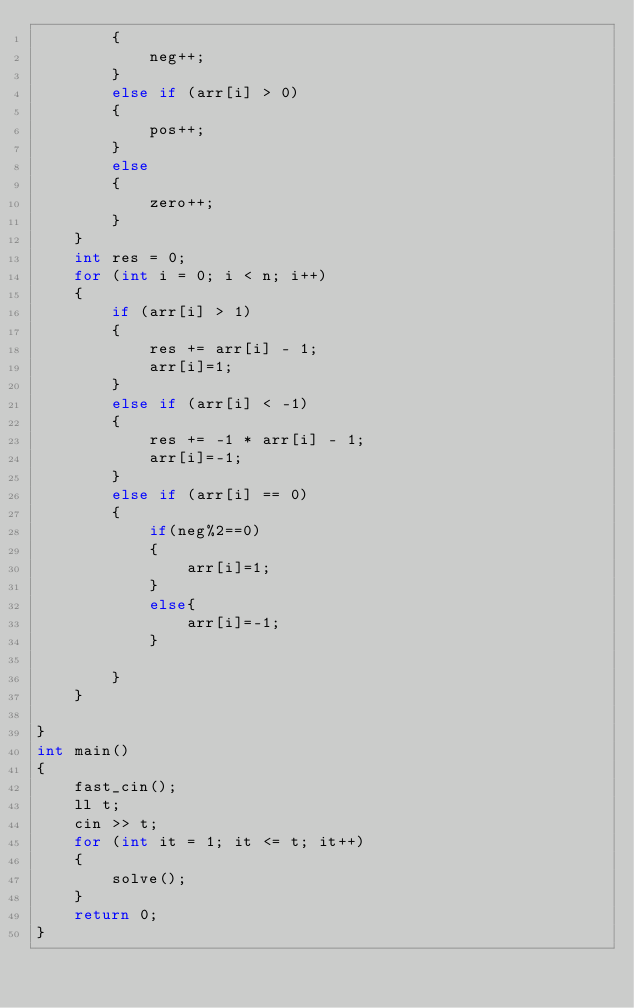Convert code to text. <code><loc_0><loc_0><loc_500><loc_500><_C++_>        {
            neg++;
        }
        else if (arr[i] > 0)
        {
            pos++;
        }
        else
        {
            zero++;
        }
    }
    int res = 0;
    for (int i = 0; i < n; i++)
    {
        if (arr[i] > 1)
        {
            res += arr[i] - 1;
            arr[i]=1;
        }
        else if (arr[i] < -1)
        {
            res += -1 * arr[i] - 1;
            arr[i]=-1;
        }
        else if (arr[i] == 0)
        {
            if(neg%2==0)
            {
                arr[i]=1;
            }
            else{
                arr[i]=-1;
            }

        }
    }
    
}
int main()
{
    fast_cin();
    ll t;
    cin >> t;
    for (int it = 1; it <= t; it++)
    {
        solve();
    }
    return 0;
}</code> 